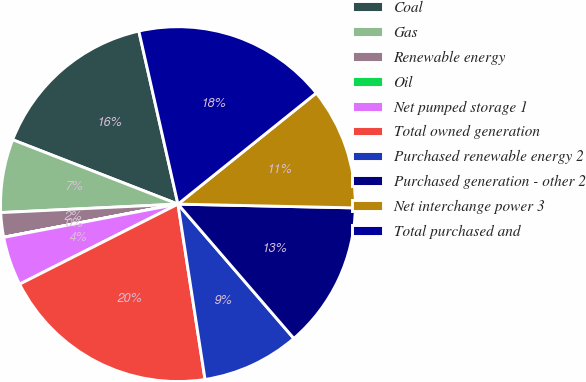<chart> <loc_0><loc_0><loc_500><loc_500><pie_chart><fcel>Coal<fcel>Gas<fcel>Renewable energy<fcel>Oil<fcel>Net pumped storage 1<fcel>Total owned generation<fcel>Purchased renewable energy 2<fcel>Purchased generation - other 2<fcel>Net interchange power 3<fcel>Total purchased and<nl><fcel>15.55%<fcel>6.67%<fcel>2.23%<fcel>0.01%<fcel>4.45%<fcel>19.99%<fcel>8.89%<fcel>13.33%<fcel>11.11%<fcel>17.77%<nl></chart> 